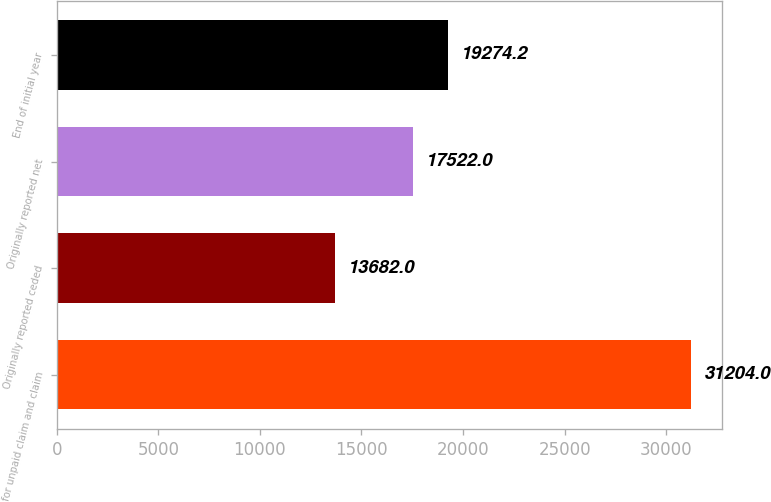Convert chart. <chart><loc_0><loc_0><loc_500><loc_500><bar_chart><fcel>for unpaid claim and claim<fcel>Originally reported ceded<fcel>Originally reported net<fcel>End of initial year<nl><fcel>31204<fcel>13682<fcel>17522<fcel>19274.2<nl></chart> 